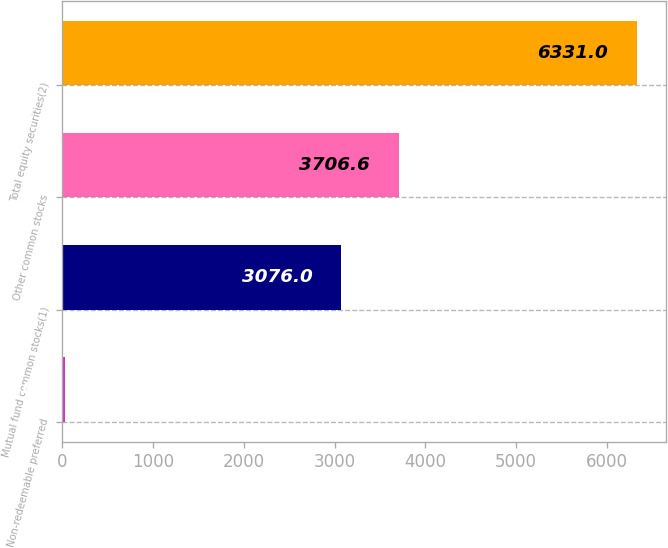Convert chart to OTSL. <chart><loc_0><loc_0><loc_500><loc_500><bar_chart><fcel>Non-redeemable preferred<fcel>Mutual fund common stocks(1)<fcel>Other common stocks<fcel>Total equity securities(2)<nl><fcel>25<fcel>3076<fcel>3706.6<fcel>6331<nl></chart> 